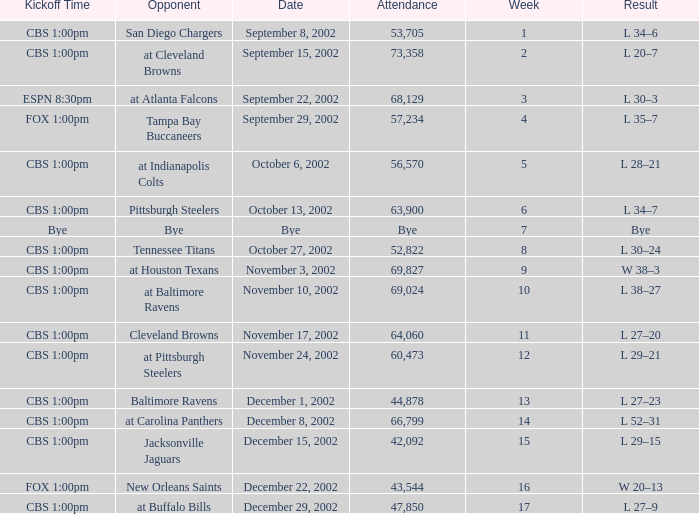What week number was the kickoff time cbs 1:00pm, with 60,473 people in attendance? 1.0. 